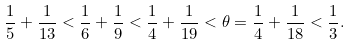<formula> <loc_0><loc_0><loc_500><loc_500>\frac { 1 } { 5 } + \frac { 1 } { 1 3 } < \frac { 1 } { 6 } + \frac { 1 } { 9 } < \frac { 1 } { 4 } + \frac { 1 } { 1 9 } < \theta = \frac { 1 } { 4 } + \frac { 1 } { 1 8 } < \frac { 1 } { 3 } .</formula> 